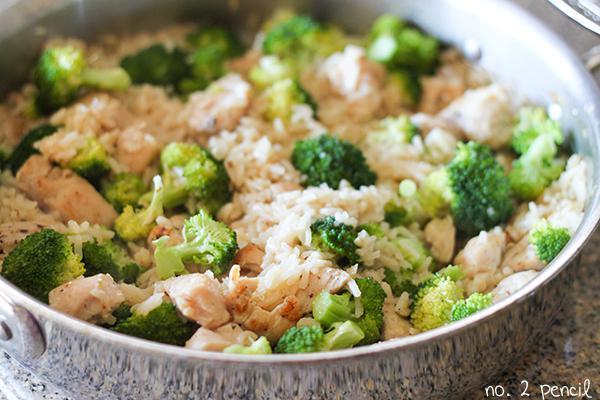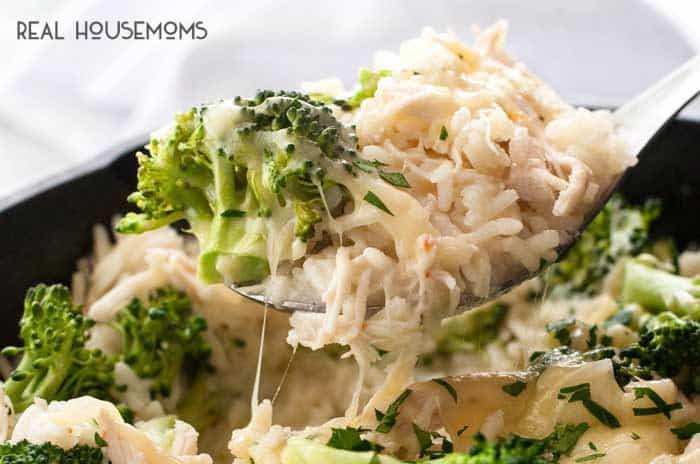The first image is the image on the left, the second image is the image on the right. Examine the images to the left and right. Is the description "Some of the food in one image is in a spoon." accurate? Answer yes or no. Yes. 